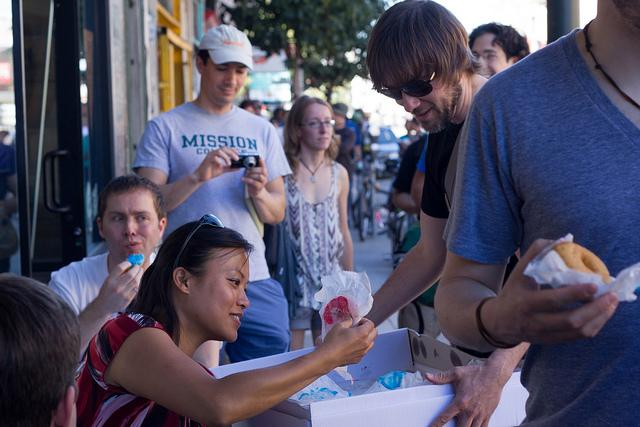What is the man wearing a hat doing with the camera?

Choices:
A) throwing it
B) selling it
C) taking pictures
D) buying it taking pictures 